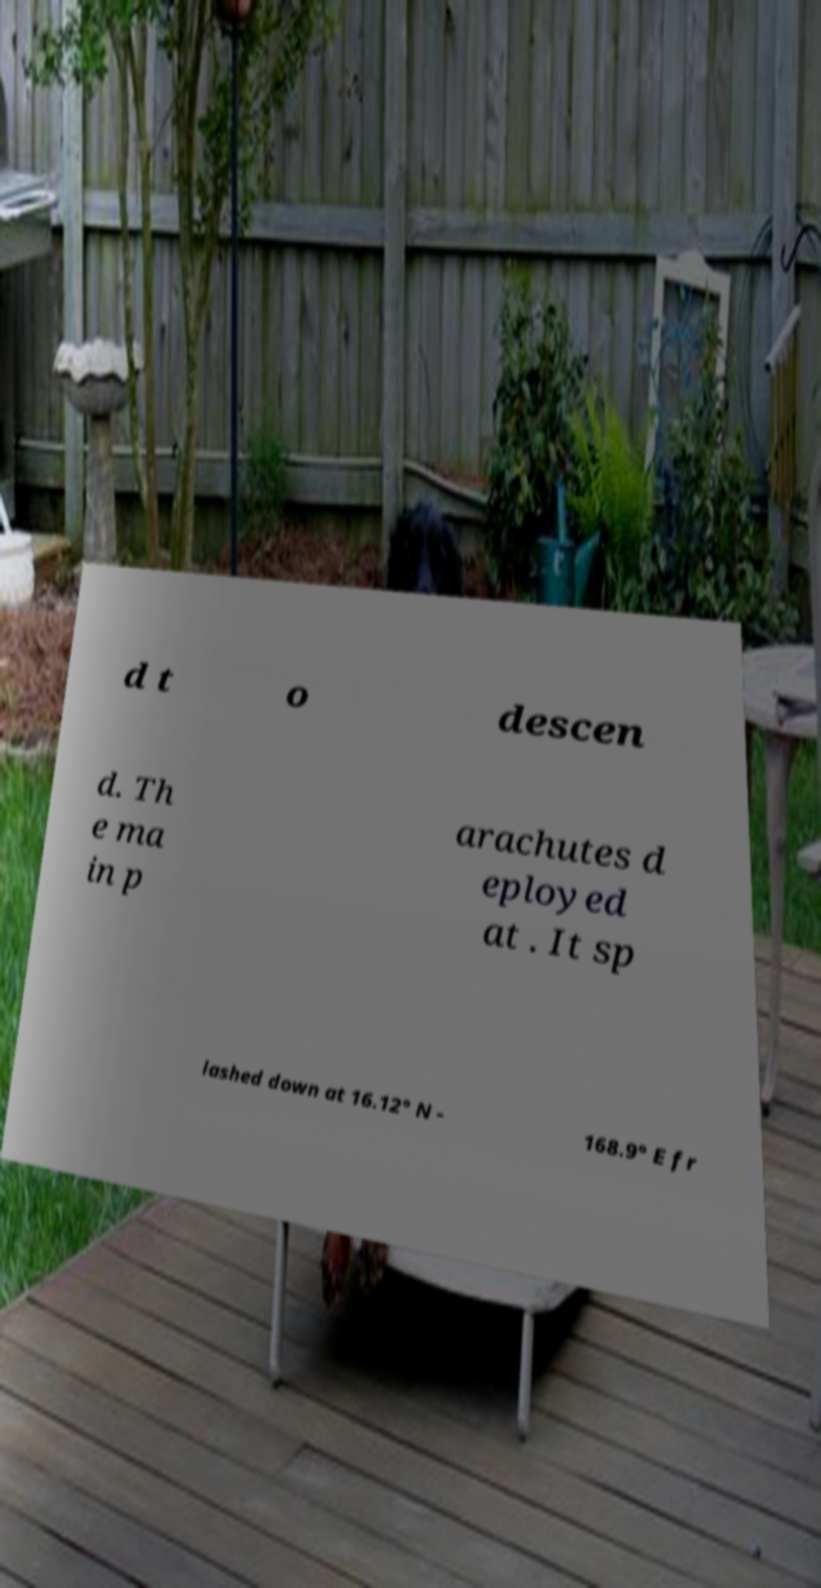There's text embedded in this image that I need extracted. Can you transcribe it verbatim? d t o descen d. Th e ma in p arachutes d eployed at . It sp lashed down at 16.12° N - 168.9° E fr 